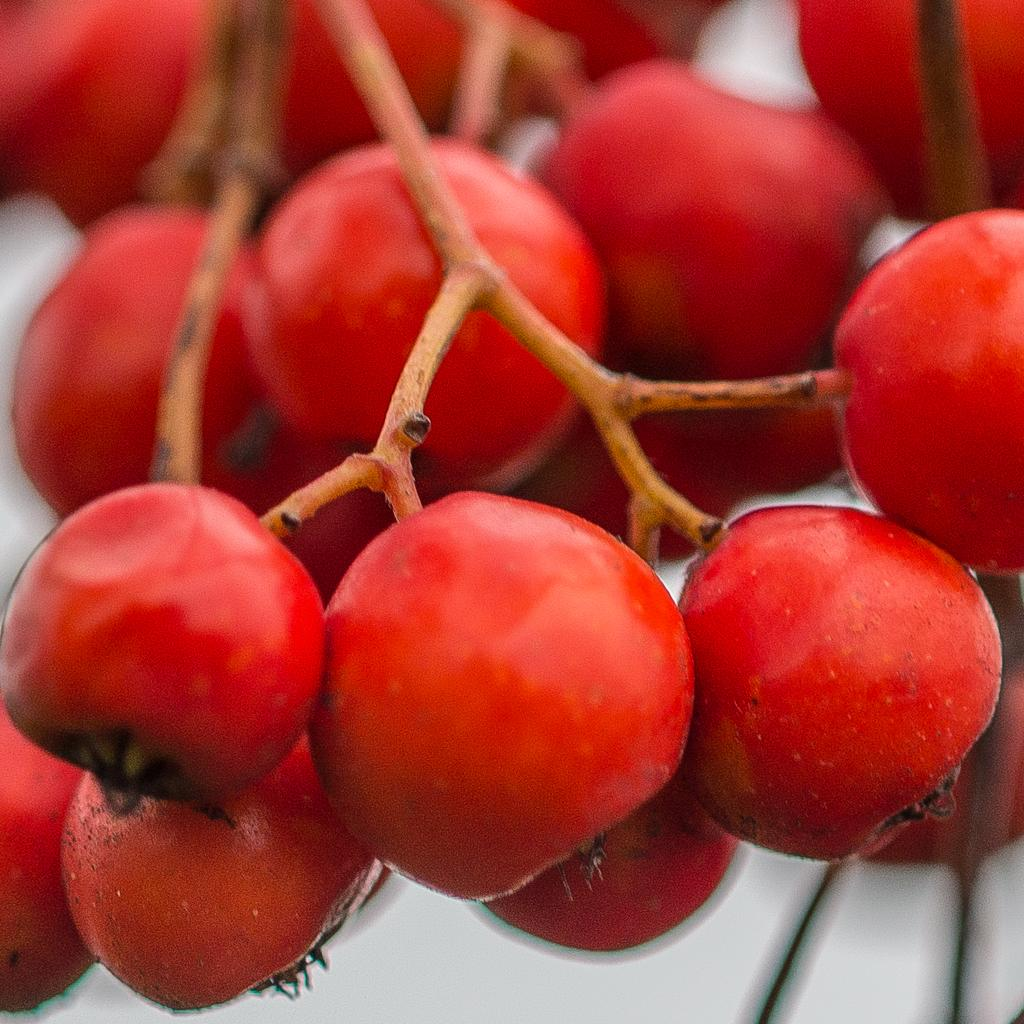What type of fruit is present in the image? There are cherries in the image. What part of the cherry is also visible in the image? There are stems in the image. What type of substance is being used to water the cherries in the image? There is no substance or watering activity present in the image; it only shows cherries and their stems. 